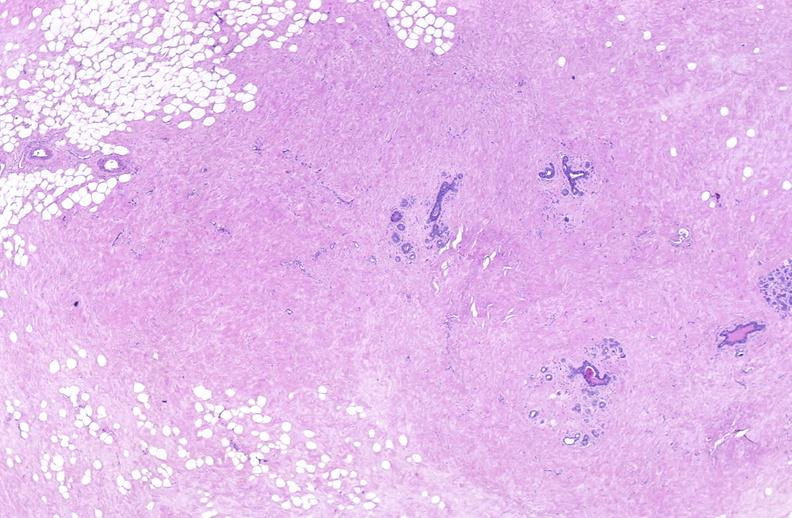where is this area in the body?
Answer the question using a single word or phrase. Breast 